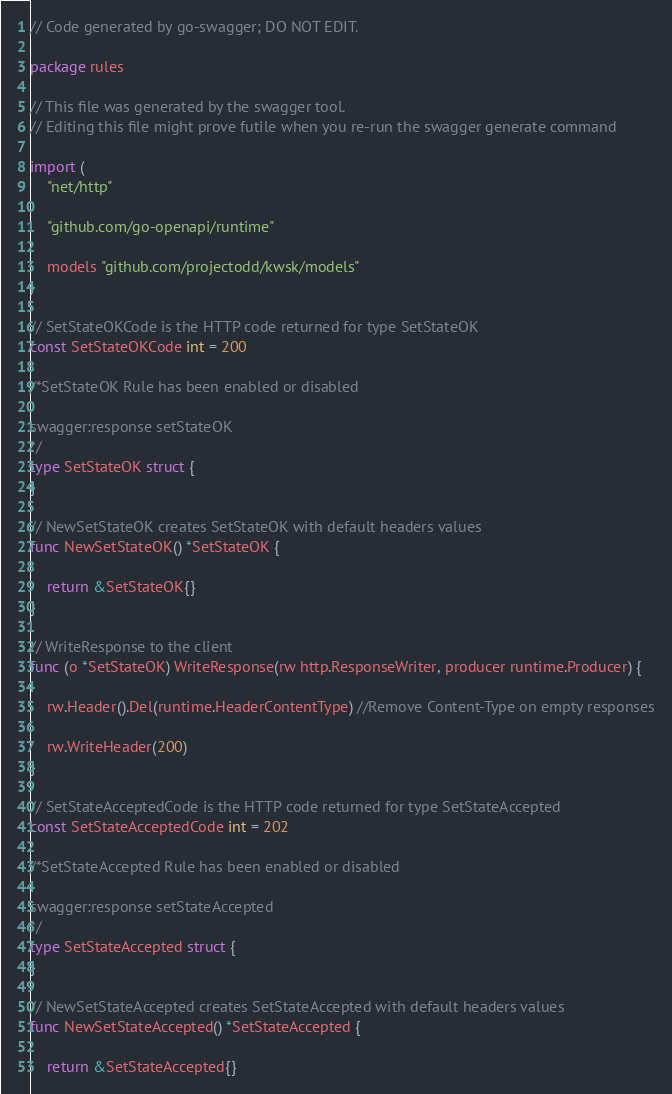<code> <loc_0><loc_0><loc_500><loc_500><_Go_>// Code generated by go-swagger; DO NOT EDIT.

package rules

// This file was generated by the swagger tool.
// Editing this file might prove futile when you re-run the swagger generate command

import (
	"net/http"

	"github.com/go-openapi/runtime"

	models "github.com/projectodd/kwsk/models"
)

// SetStateOKCode is the HTTP code returned for type SetStateOK
const SetStateOKCode int = 200

/*SetStateOK Rule has been enabled or disabled

swagger:response setStateOK
*/
type SetStateOK struct {
}

// NewSetStateOK creates SetStateOK with default headers values
func NewSetStateOK() *SetStateOK {

	return &SetStateOK{}
}

// WriteResponse to the client
func (o *SetStateOK) WriteResponse(rw http.ResponseWriter, producer runtime.Producer) {

	rw.Header().Del(runtime.HeaderContentType) //Remove Content-Type on empty responses

	rw.WriteHeader(200)
}

// SetStateAcceptedCode is the HTTP code returned for type SetStateAccepted
const SetStateAcceptedCode int = 202

/*SetStateAccepted Rule has been enabled or disabled

swagger:response setStateAccepted
*/
type SetStateAccepted struct {
}

// NewSetStateAccepted creates SetStateAccepted with default headers values
func NewSetStateAccepted() *SetStateAccepted {

	return &SetStateAccepted{}</code> 